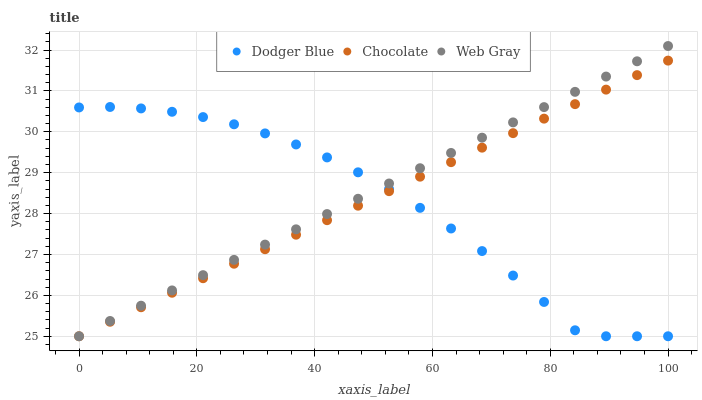Does Dodger Blue have the minimum area under the curve?
Answer yes or no. Yes. Does Web Gray have the maximum area under the curve?
Answer yes or no. Yes. Does Chocolate have the minimum area under the curve?
Answer yes or no. No. Does Chocolate have the maximum area under the curve?
Answer yes or no. No. Is Chocolate the smoothest?
Answer yes or no. Yes. Is Dodger Blue the roughest?
Answer yes or no. Yes. Is Dodger Blue the smoothest?
Answer yes or no. No. Is Chocolate the roughest?
Answer yes or no. No. Does Web Gray have the lowest value?
Answer yes or no. Yes. Does Web Gray have the highest value?
Answer yes or no. Yes. Does Chocolate have the highest value?
Answer yes or no. No. Does Dodger Blue intersect Chocolate?
Answer yes or no. Yes. Is Dodger Blue less than Chocolate?
Answer yes or no. No. Is Dodger Blue greater than Chocolate?
Answer yes or no. No. 